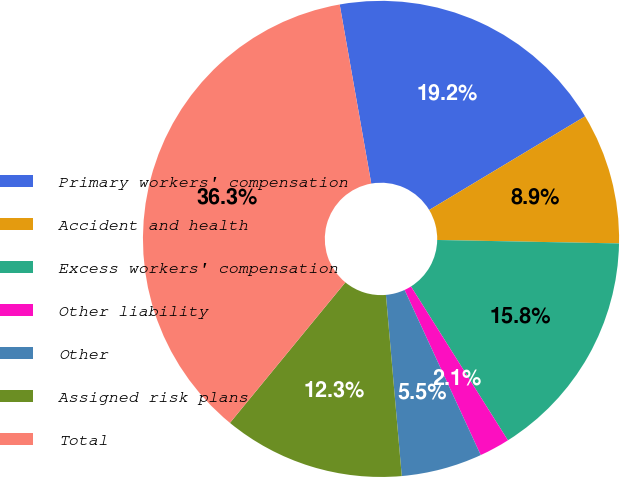Convert chart. <chart><loc_0><loc_0><loc_500><loc_500><pie_chart><fcel>Primary workers' compensation<fcel>Accident and health<fcel>Excess workers' compensation<fcel>Other liability<fcel>Other<fcel>Assigned risk plans<fcel>Total<nl><fcel>19.17%<fcel>8.91%<fcel>15.75%<fcel>2.07%<fcel>5.49%<fcel>12.33%<fcel>36.28%<nl></chart> 